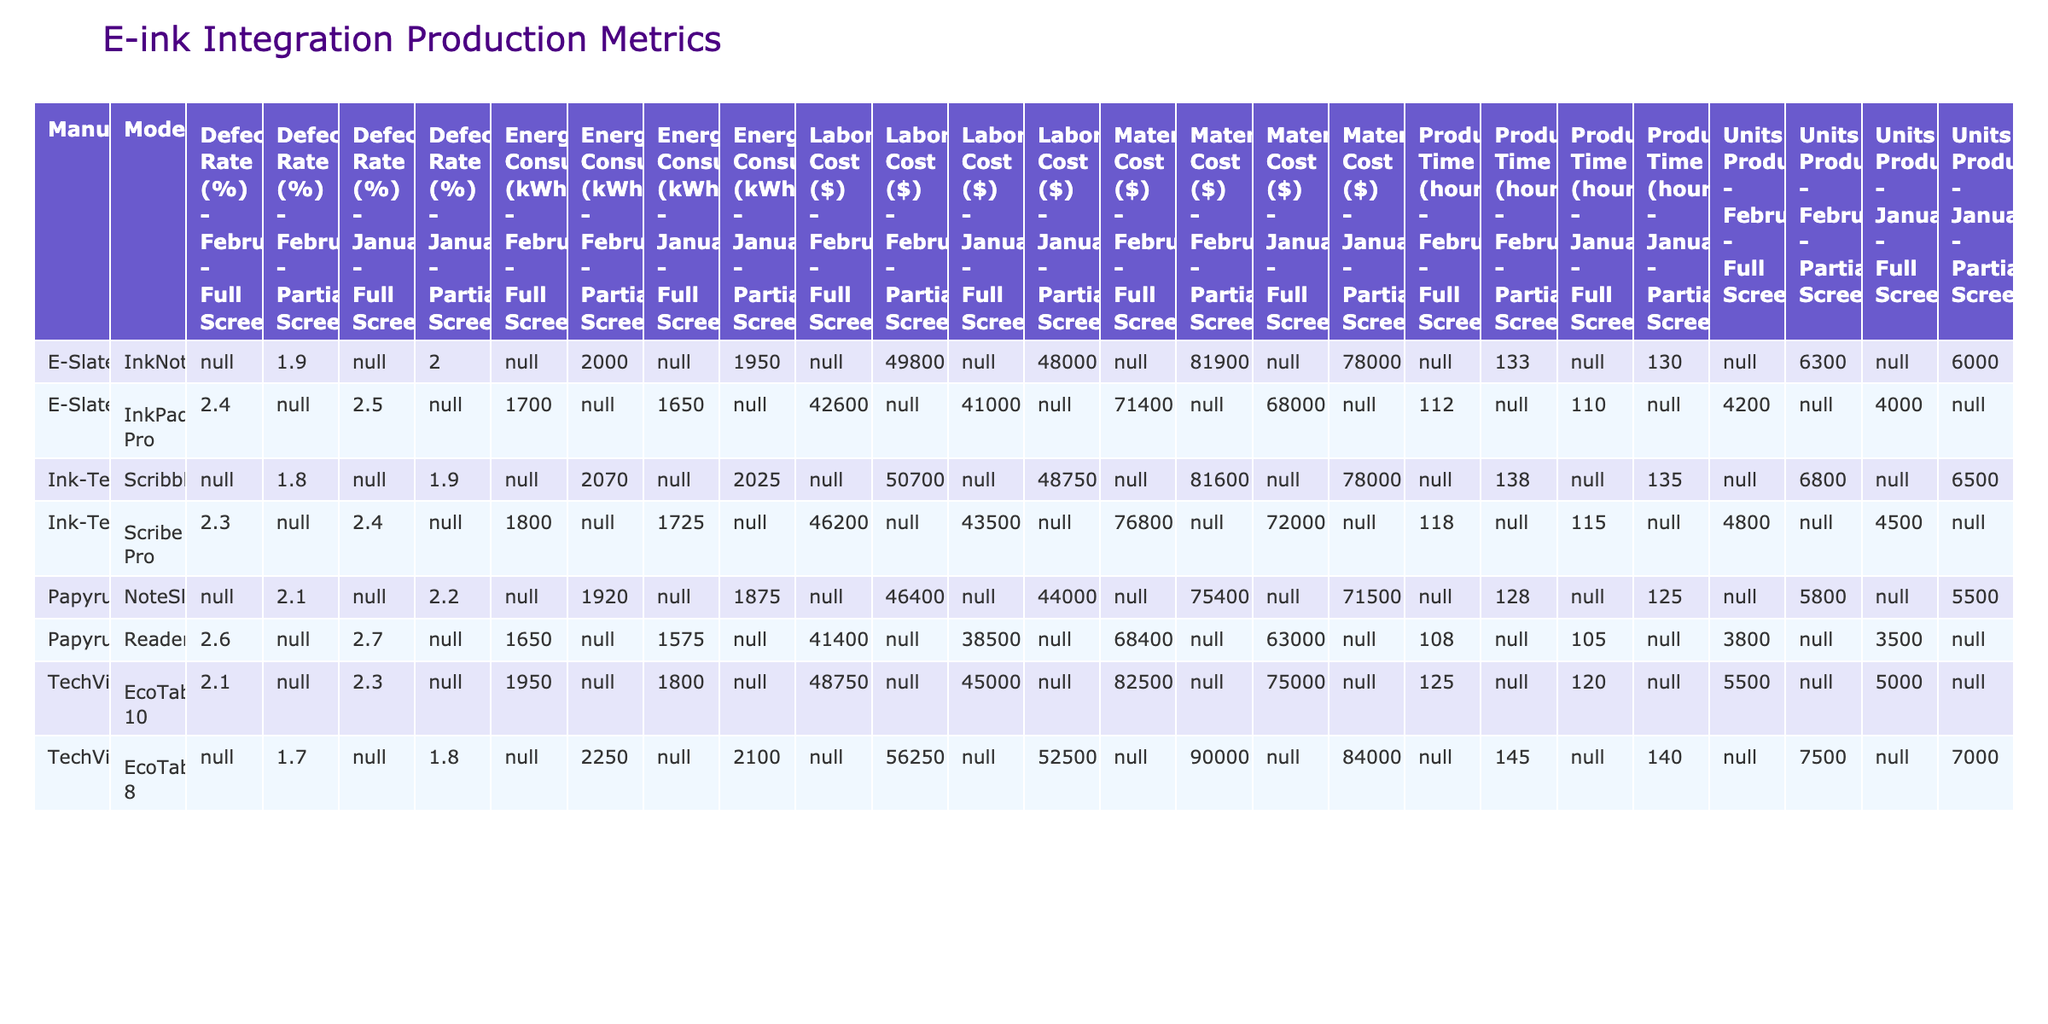What is the lowest defect rate recorded for any model in January? In the month of January, the defect rates for the models are as follows: EcoTab 10 (2.3%), EcoTab 8 (1.8%), InkPad Pro (2.5%), InkNote (2.0%), ReaderPlus (2.7%), NoteSlate (2.2%), Scribe Pro (2.4%), and Scribble (1.9%). The lowest defect rate among these is 1.8% for the EcoTab 8.
Answer: 1.8% Which model had the highest total production time in February? In February, the production times for each model are: EcoTab 10 (125 hours), EcoTab 8 (145 hours), InkPad Pro (112 hours), InkNote (133 hours), ReaderPlus (108 hours), NoteSlate (128 hours), Scribe Pro (118 hours), and Scribble (138 hours). The model with the highest production time is EcoTab 8 with 145 hours.
Answer: EcoTab 8 Is the energy consumption for the EcoTab 10 in January higher than that of the Scribe Pro in January? The energy consumption for EcoTab 10 in January is 1800 kWh and for Scribe Pro is 1725 kWh. Since 1800 > 1725, the consumption for EcoTab 10 is indeed higher.
Answer: Yes What is the average defect rate of the InkNote model over both months? The defect rates for the InkNote model are 2.0% in January and 1.9% in February. To find the average, we calculate (2.0 + 1.9) / 2 = 1.95. Therefore, the average defect rate is 1.95%.
Answer: 1.95% How do the total units produced for Full Screen models in January compare to those in February? In January, the units produced for Full Screen models are: EcoTab 10 (5000), InkPad Pro (4000), ReaderPlus (3500), and Scribe Pro (4500), summing to 17000. In February, the respective figures are: EcoTab 10 (5500), InkPad Pro (4200), ReaderPlus (3800), and Scribe Pro (4800), summing to 18300. Therefore, the number of units produced increased from January to February.
Answer: Increased What is the total labor cost for all Partial Screen models in both January and February? For Partial Screen models, the January labor costs are: EcoTab 8 ($52500), InkNote ($48000), NoteSlate ($44000), and Scribble ($48750). This totals $193250. In February, the costs are EcoTab 8 ($56250), InkNote ($49800), NoteSlate ($46400), and Scribble ($50700), totaling $203150. Adding these two sums gives $396400 as the total labor cost.
Answer: $396400 